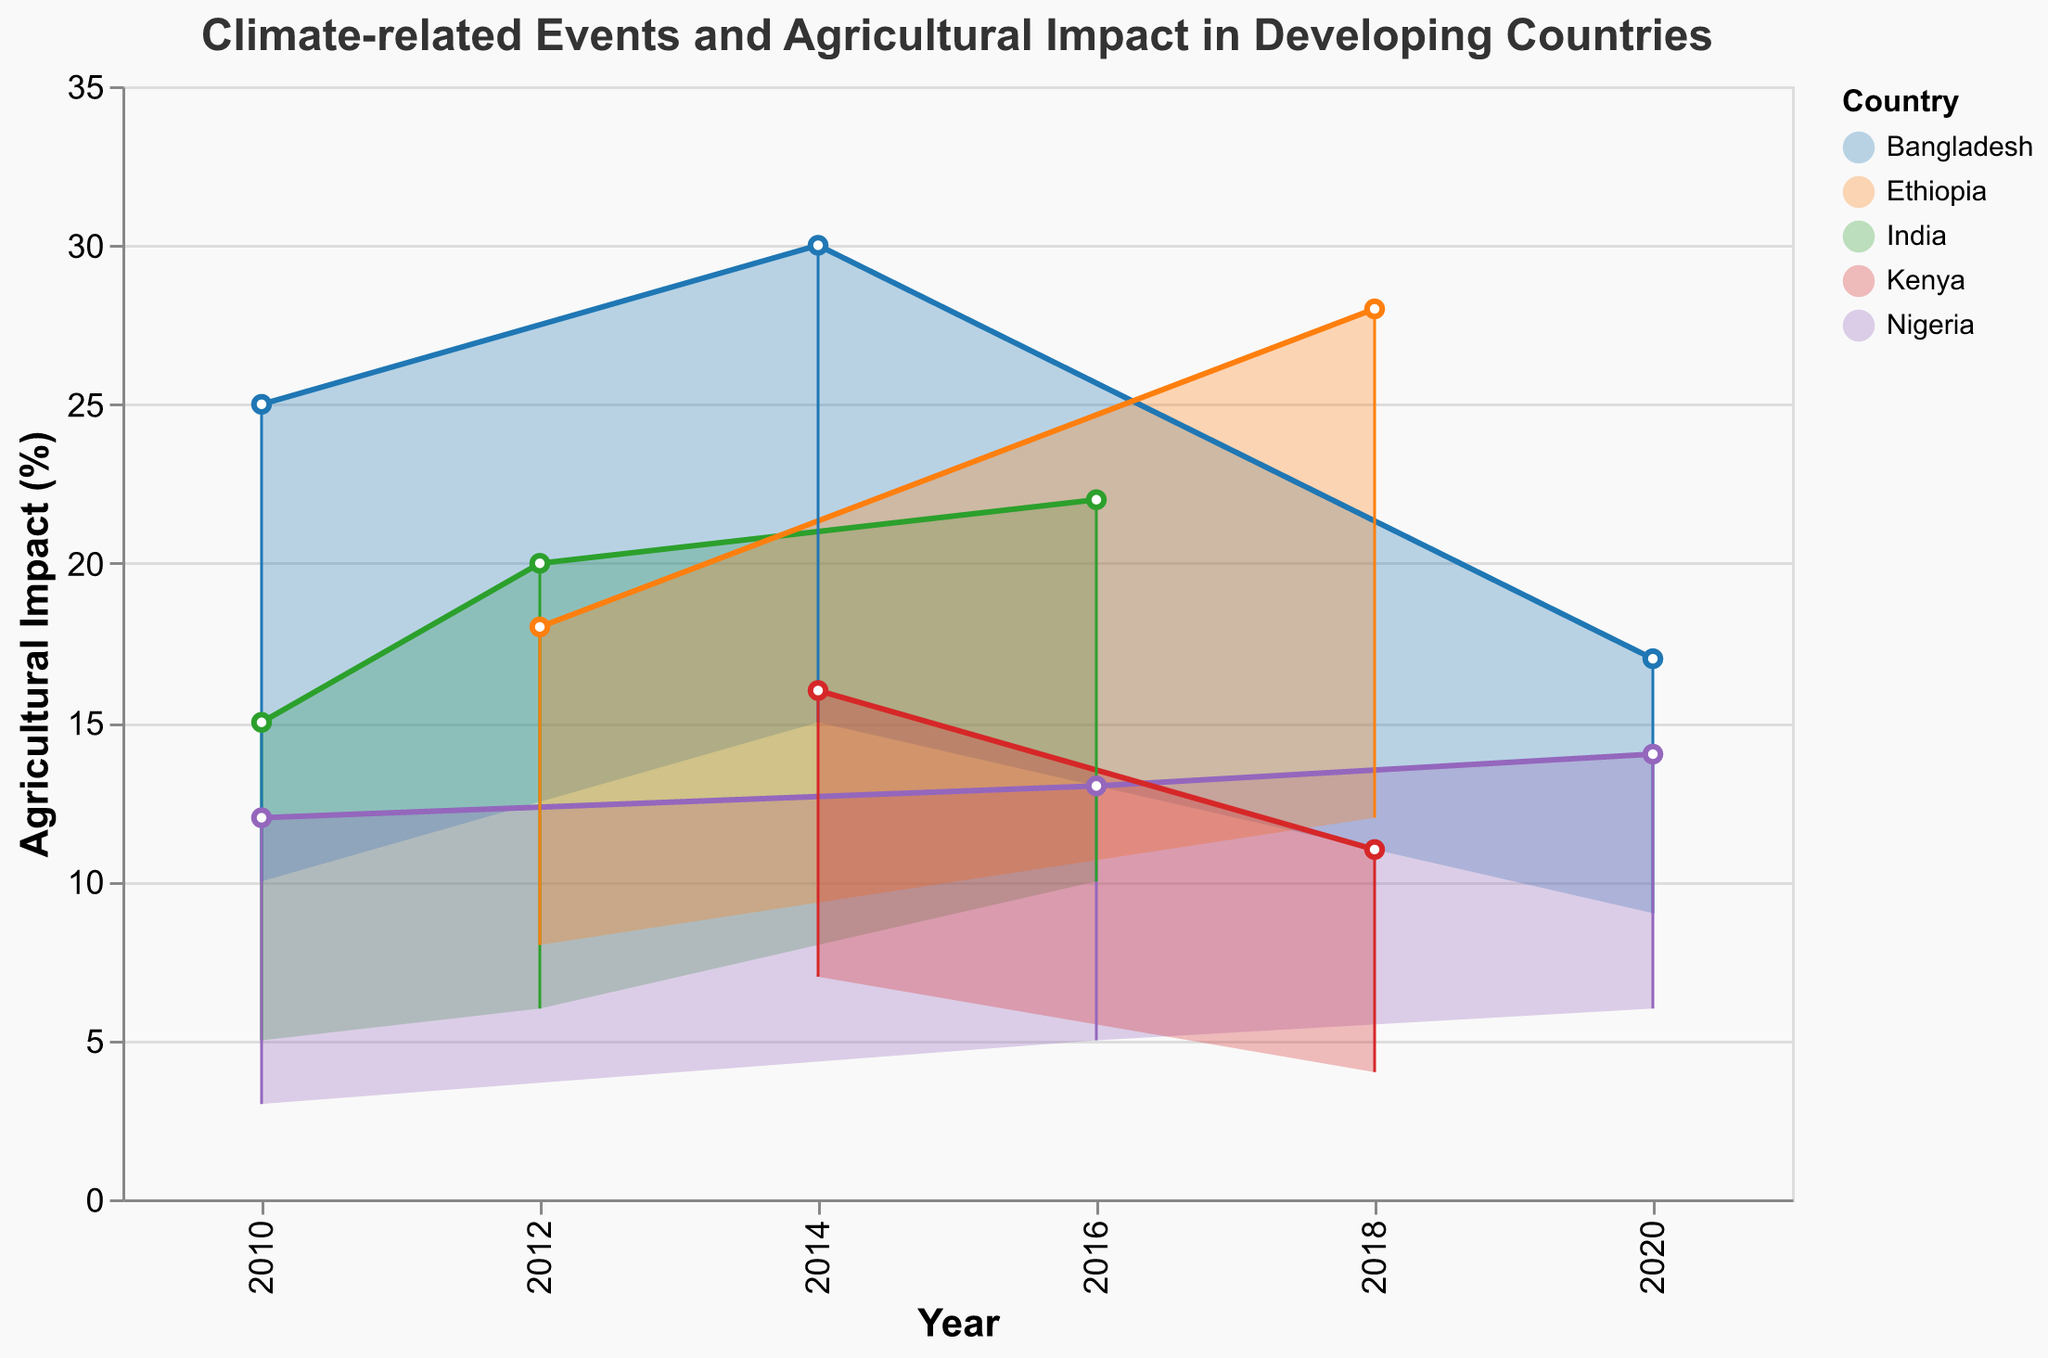What's the title of the chart? The title is the text at the top of the chart.
Answer: Climate-related Events and Agricultural Impact in Developing Countries Which country experienced flooding events in 2010? Look at the "Event" and "Country" data points for 2010.
Answer: Bangladesh What is the range of agricultural impact for the drought event in India in 2010? Check the "Min Impact (%)" and "Max Impact (%)" for the drought event in India in 2010.
Answer: 5% to 15% Which country had the highest maximum impact in any year, and what was that impact? Examine the "Max Impact (%)" across all countries and years to find the highest value, then identify the corresponding country.
Answer: Bangladesh, 30% How many countries experienced drought events between 2010 and 2020? Count the occurrences of the drought events for different countries in the given time range.
Answer: 4 (India, Ethiopia, Kenya, Bangladesh) In which year did Nigeria experience multiple climate-related events, and what were they? Look at the entries for Nigeria and list the events from the same year.
Answer: 2010, Heatwave Compare the agricultural impact range for drought events in India between 2010 and 2016. Which year had a greater maximum impact? Compare the "Max Impact (%)" for drought events in India in 2010 and 2016.
Answer: 2016 (22%) What's the average minimum impact for flooding events in Bangladesh? Add up the "Min Impact (%)" values for flooding events in Bangladesh and divide by the number of events. In this case, (10 + 15) / 2.
Answer: 12.5% Which event had the lowest minimum impact in 2018, and what was it? Check the "Min Impact (%)" values for 2018 and find the lowest one, then identify the event.
Answer: Heatwave, 4% Which country showed the most varied range in agricultural impact for flooding events over the years? Compare the differences between "Min Impact (%)" and "Max Impact (%)" for flooding events in each country.
Answer: Bangladesh 